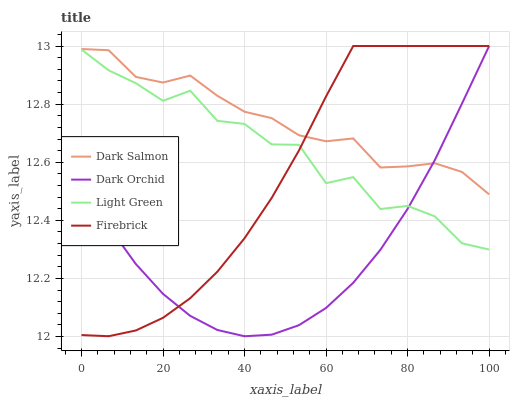Does Dark Orchid have the minimum area under the curve?
Answer yes or no. Yes. Does Dark Salmon have the maximum area under the curve?
Answer yes or no. Yes. Does Light Green have the minimum area under the curve?
Answer yes or no. No. Does Light Green have the maximum area under the curve?
Answer yes or no. No. Is Dark Orchid the smoothest?
Answer yes or no. Yes. Is Light Green the roughest?
Answer yes or no. Yes. Is Dark Salmon the smoothest?
Answer yes or no. No. Is Dark Salmon the roughest?
Answer yes or no. No. Does Dark Orchid have the lowest value?
Answer yes or no. Yes. Does Light Green have the lowest value?
Answer yes or no. No. Does Dark Orchid have the highest value?
Answer yes or no. Yes. Does Dark Salmon have the highest value?
Answer yes or no. No. Is Light Green less than Dark Salmon?
Answer yes or no. Yes. Is Dark Salmon greater than Light Green?
Answer yes or no. Yes. Does Dark Salmon intersect Dark Orchid?
Answer yes or no. Yes. Is Dark Salmon less than Dark Orchid?
Answer yes or no. No. Is Dark Salmon greater than Dark Orchid?
Answer yes or no. No. Does Light Green intersect Dark Salmon?
Answer yes or no. No. 